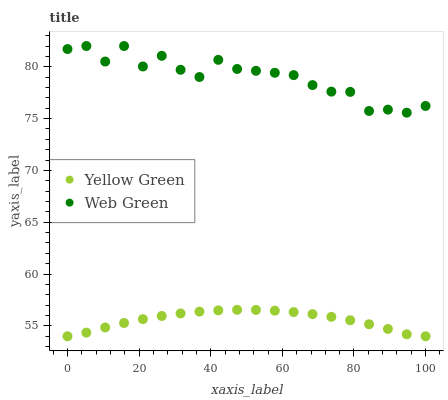Does Yellow Green have the minimum area under the curve?
Answer yes or no. Yes. Does Web Green have the maximum area under the curve?
Answer yes or no. Yes. Does Web Green have the minimum area under the curve?
Answer yes or no. No. Is Yellow Green the smoothest?
Answer yes or no. Yes. Is Web Green the roughest?
Answer yes or no. Yes. Is Web Green the smoothest?
Answer yes or no. No. Does Yellow Green have the lowest value?
Answer yes or no. Yes. Does Web Green have the lowest value?
Answer yes or no. No. Does Web Green have the highest value?
Answer yes or no. Yes. Is Yellow Green less than Web Green?
Answer yes or no. Yes. Is Web Green greater than Yellow Green?
Answer yes or no. Yes. Does Yellow Green intersect Web Green?
Answer yes or no. No. 